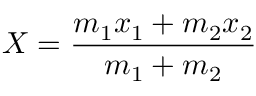Convert formula to latex. <formula><loc_0><loc_0><loc_500><loc_500>X = { \frac { m _ { 1 } x _ { 1 } + m _ { 2 } x _ { 2 } } { m _ { 1 } + m _ { 2 } } }</formula> 